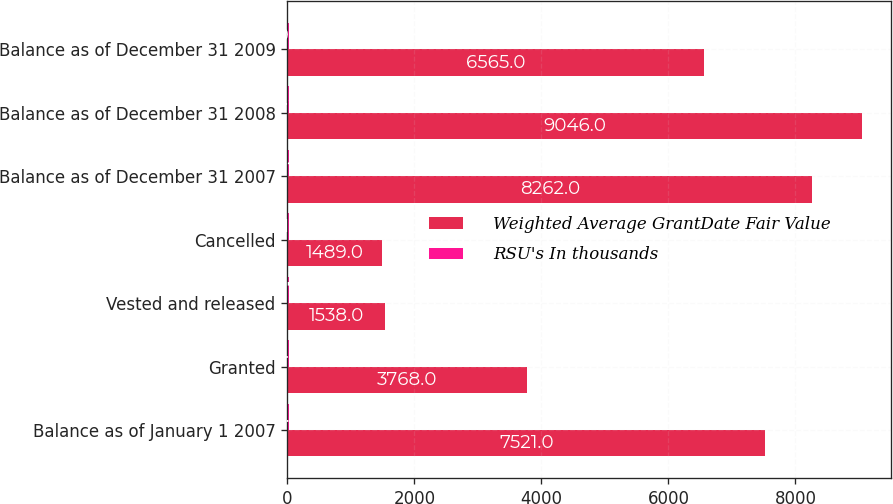Convert chart to OTSL. <chart><loc_0><loc_0><loc_500><loc_500><stacked_bar_chart><ecel><fcel>Balance as of January 1 2007<fcel>Granted<fcel>Vested and released<fcel>Cancelled<fcel>Balance as of December 31 2007<fcel>Balance as of December 31 2008<fcel>Balance as of December 31 2009<nl><fcel>Weighted Average GrantDate Fair Value<fcel>7521<fcel>3768<fcel>1538<fcel>1489<fcel>8262<fcel>9046<fcel>6565<nl><fcel>RSU's In thousands<fcel>20.72<fcel>22.92<fcel>21.72<fcel>21.2<fcel>21.43<fcel>21.41<fcel>19.5<nl></chart> 